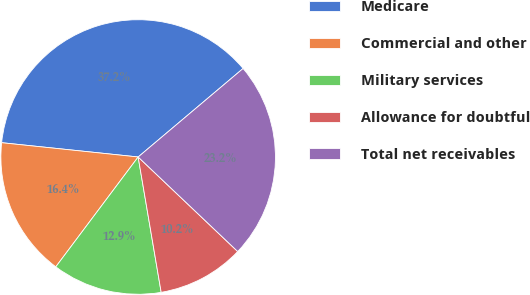<chart> <loc_0><loc_0><loc_500><loc_500><pie_chart><fcel>Medicare<fcel>Commercial and other<fcel>Military services<fcel>Allowance for doubtful<fcel>Total net receivables<nl><fcel>37.19%<fcel>16.42%<fcel>12.92%<fcel>10.23%<fcel>23.24%<nl></chart> 